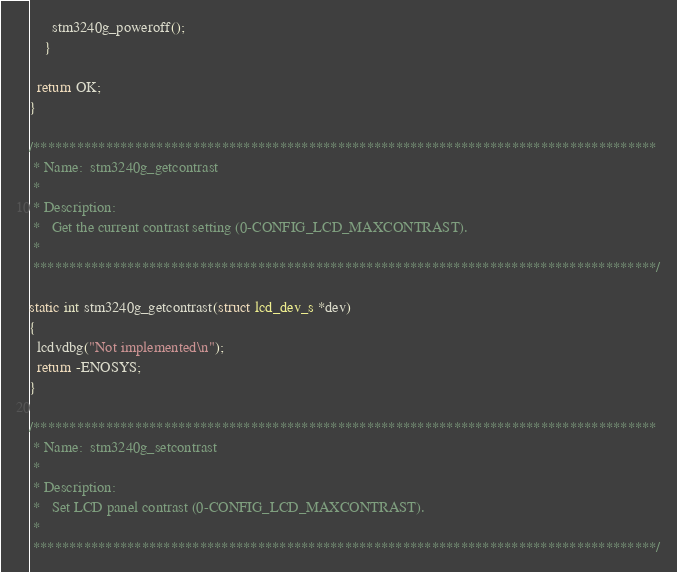<code> <loc_0><loc_0><loc_500><loc_500><_C_>      stm3240g_poweroff();
    }

  return OK;
}

/**************************************************************************************
 * Name:  stm3240g_getcontrast
 *
 * Description:
 *   Get the current contrast setting (0-CONFIG_LCD_MAXCONTRAST).
 *
 **************************************************************************************/

static int stm3240g_getcontrast(struct lcd_dev_s *dev)
{
  lcdvdbg("Not implemented\n");
  return -ENOSYS;
}

/**************************************************************************************
 * Name:  stm3240g_setcontrast
 *
 * Description:
 *   Set LCD panel contrast (0-CONFIG_LCD_MAXCONTRAST).
 *
 **************************************************************************************/
</code> 